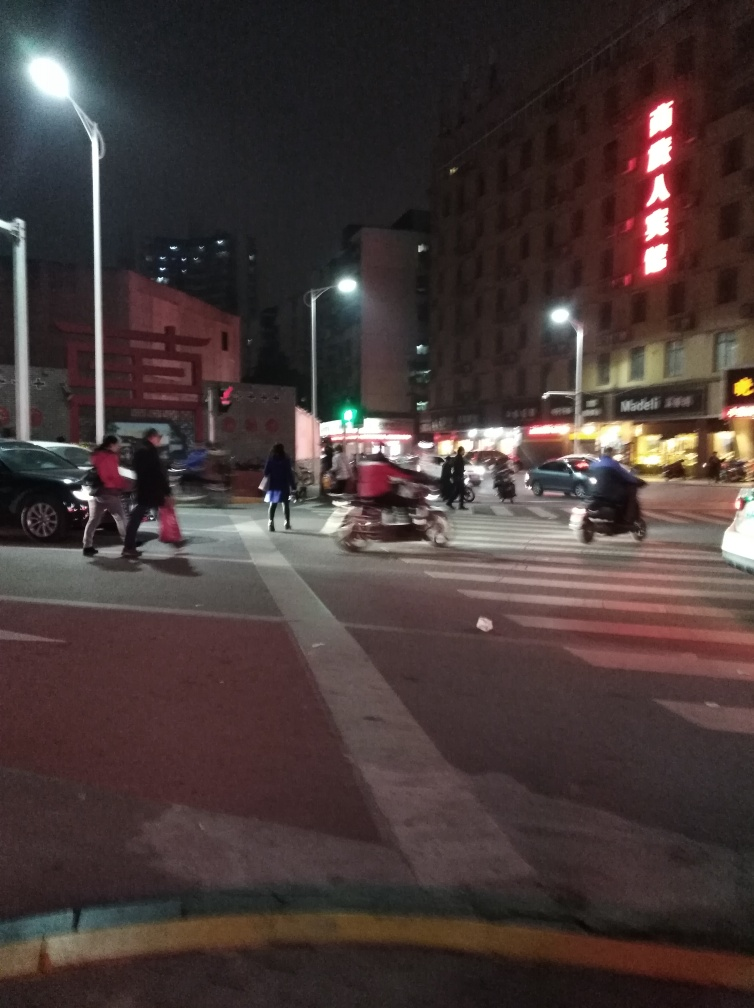Are there any safety concerns visible in the image? From the image, one safety concern might be the mix of pedestrian and vehicle traffic, with a pedestrian crossing the street and vehicles in close proximity. It's also apparent that the image is taken at night with moderate lighting, which can pose visibility issues for both drivers and pedestrians. Should pedestrians and drivers take any specific precautions in such conditions? Yes, in such conditions, pedestrians should ensure they are visible to drivers, make eye contact with drivers before crossing, and follow traffic signals. Drivers should remain alert, reduce speed, and be prepared for pedestrians unexpectedly crossing, especially in poorly lit areas. 